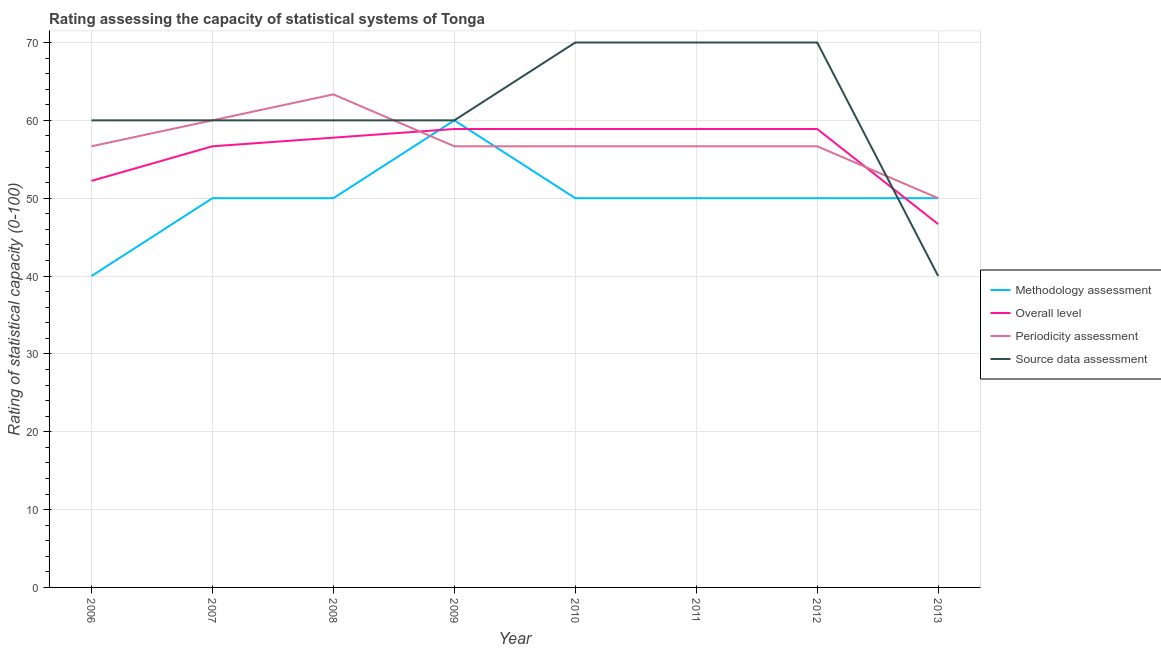How many different coloured lines are there?
Keep it short and to the point. 4. Does the line corresponding to methodology assessment rating intersect with the line corresponding to periodicity assessment rating?
Make the answer very short. Yes. What is the methodology assessment rating in 2009?
Offer a very short reply. 60. Across all years, what is the maximum methodology assessment rating?
Offer a terse response. 60. Across all years, what is the minimum methodology assessment rating?
Keep it short and to the point. 40. In which year was the overall level rating maximum?
Make the answer very short. 2009. In which year was the source data assessment rating minimum?
Make the answer very short. 2013. What is the total methodology assessment rating in the graph?
Make the answer very short. 400. What is the difference between the overall level rating in 2008 and that in 2009?
Make the answer very short. -1.11. What is the difference between the methodology assessment rating in 2007 and the periodicity assessment rating in 2010?
Ensure brevity in your answer.  -6.67. What is the average periodicity assessment rating per year?
Offer a very short reply. 57.08. In the year 2008, what is the difference between the overall level rating and source data assessment rating?
Your answer should be very brief. -2.22. What is the ratio of the source data assessment rating in 2007 to that in 2013?
Your response must be concise. 1.5. Is the source data assessment rating in 2011 less than that in 2012?
Your answer should be compact. No. What is the difference between the highest and the second highest periodicity assessment rating?
Keep it short and to the point. 3.33. What is the difference between the highest and the lowest overall level rating?
Ensure brevity in your answer.  12.22. In how many years, is the overall level rating greater than the average overall level rating taken over all years?
Your answer should be very brief. 6. Is it the case that in every year, the sum of the methodology assessment rating and overall level rating is greater than the periodicity assessment rating?
Offer a very short reply. Yes. Does the overall level rating monotonically increase over the years?
Provide a short and direct response. No. Is the periodicity assessment rating strictly greater than the source data assessment rating over the years?
Your response must be concise. No. How many lines are there?
Offer a very short reply. 4. How many years are there in the graph?
Provide a short and direct response. 8. Are the values on the major ticks of Y-axis written in scientific E-notation?
Your response must be concise. No. Where does the legend appear in the graph?
Provide a succinct answer. Center right. How many legend labels are there?
Ensure brevity in your answer.  4. What is the title of the graph?
Provide a short and direct response. Rating assessing the capacity of statistical systems of Tonga. What is the label or title of the Y-axis?
Make the answer very short. Rating of statistical capacity (0-100). What is the Rating of statistical capacity (0-100) in Overall level in 2006?
Make the answer very short. 52.22. What is the Rating of statistical capacity (0-100) of Periodicity assessment in 2006?
Offer a terse response. 56.67. What is the Rating of statistical capacity (0-100) of Methodology assessment in 2007?
Provide a short and direct response. 50. What is the Rating of statistical capacity (0-100) of Overall level in 2007?
Offer a very short reply. 56.67. What is the Rating of statistical capacity (0-100) of Periodicity assessment in 2007?
Keep it short and to the point. 60. What is the Rating of statistical capacity (0-100) of Source data assessment in 2007?
Provide a short and direct response. 60. What is the Rating of statistical capacity (0-100) of Overall level in 2008?
Offer a terse response. 57.78. What is the Rating of statistical capacity (0-100) in Periodicity assessment in 2008?
Make the answer very short. 63.33. What is the Rating of statistical capacity (0-100) of Overall level in 2009?
Make the answer very short. 58.89. What is the Rating of statistical capacity (0-100) of Periodicity assessment in 2009?
Provide a short and direct response. 56.67. What is the Rating of statistical capacity (0-100) of Methodology assessment in 2010?
Make the answer very short. 50. What is the Rating of statistical capacity (0-100) in Overall level in 2010?
Provide a succinct answer. 58.89. What is the Rating of statistical capacity (0-100) in Periodicity assessment in 2010?
Provide a succinct answer. 56.67. What is the Rating of statistical capacity (0-100) in Methodology assessment in 2011?
Offer a terse response. 50. What is the Rating of statistical capacity (0-100) in Overall level in 2011?
Your response must be concise. 58.89. What is the Rating of statistical capacity (0-100) in Periodicity assessment in 2011?
Your answer should be compact. 56.67. What is the Rating of statistical capacity (0-100) in Source data assessment in 2011?
Ensure brevity in your answer.  70. What is the Rating of statistical capacity (0-100) of Overall level in 2012?
Provide a short and direct response. 58.89. What is the Rating of statistical capacity (0-100) in Periodicity assessment in 2012?
Give a very brief answer. 56.67. What is the Rating of statistical capacity (0-100) in Source data assessment in 2012?
Your answer should be compact. 70. What is the Rating of statistical capacity (0-100) of Overall level in 2013?
Offer a terse response. 46.67. What is the Rating of statistical capacity (0-100) in Source data assessment in 2013?
Offer a terse response. 40. Across all years, what is the maximum Rating of statistical capacity (0-100) of Overall level?
Offer a very short reply. 58.89. Across all years, what is the maximum Rating of statistical capacity (0-100) of Periodicity assessment?
Ensure brevity in your answer.  63.33. Across all years, what is the maximum Rating of statistical capacity (0-100) in Source data assessment?
Your answer should be very brief. 70. Across all years, what is the minimum Rating of statistical capacity (0-100) of Methodology assessment?
Make the answer very short. 40. Across all years, what is the minimum Rating of statistical capacity (0-100) in Overall level?
Your answer should be compact. 46.67. Across all years, what is the minimum Rating of statistical capacity (0-100) of Periodicity assessment?
Your answer should be compact. 50. Across all years, what is the minimum Rating of statistical capacity (0-100) in Source data assessment?
Your response must be concise. 40. What is the total Rating of statistical capacity (0-100) in Overall level in the graph?
Your answer should be very brief. 448.89. What is the total Rating of statistical capacity (0-100) in Periodicity assessment in the graph?
Your answer should be compact. 456.67. What is the total Rating of statistical capacity (0-100) in Source data assessment in the graph?
Your answer should be very brief. 490. What is the difference between the Rating of statistical capacity (0-100) of Methodology assessment in 2006 and that in 2007?
Make the answer very short. -10. What is the difference between the Rating of statistical capacity (0-100) in Overall level in 2006 and that in 2007?
Offer a very short reply. -4.44. What is the difference between the Rating of statistical capacity (0-100) in Periodicity assessment in 2006 and that in 2007?
Provide a succinct answer. -3.33. What is the difference between the Rating of statistical capacity (0-100) of Source data assessment in 2006 and that in 2007?
Provide a short and direct response. 0. What is the difference between the Rating of statistical capacity (0-100) of Methodology assessment in 2006 and that in 2008?
Your response must be concise. -10. What is the difference between the Rating of statistical capacity (0-100) of Overall level in 2006 and that in 2008?
Your response must be concise. -5.56. What is the difference between the Rating of statistical capacity (0-100) of Periodicity assessment in 2006 and that in 2008?
Ensure brevity in your answer.  -6.67. What is the difference between the Rating of statistical capacity (0-100) in Overall level in 2006 and that in 2009?
Your answer should be very brief. -6.67. What is the difference between the Rating of statistical capacity (0-100) in Periodicity assessment in 2006 and that in 2009?
Your response must be concise. 0. What is the difference between the Rating of statistical capacity (0-100) of Overall level in 2006 and that in 2010?
Your answer should be very brief. -6.67. What is the difference between the Rating of statistical capacity (0-100) in Source data assessment in 2006 and that in 2010?
Your answer should be compact. -10. What is the difference between the Rating of statistical capacity (0-100) in Methodology assessment in 2006 and that in 2011?
Offer a terse response. -10. What is the difference between the Rating of statistical capacity (0-100) in Overall level in 2006 and that in 2011?
Provide a succinct answer. -6.67. What is the difference between the Rating of statistical capacity (0-100) in Overall level in 2006 and that in 2012?
Your answer should be very brief. -6.67. What is the difference between the Rating of statistical capacity (0-100) of Methodology assessment in 2006 and that in 2013?
Keep it short and to the point. -10. What is the difference between the Rating of statistical capacity (0-100) in Overall level in 2006 and that in 2013?
Provide a succinct answer. 5.56. What is the difference between the Rating of statistical capacity (0-100) of Overall level in 2007 and that in 2008?
Offer a very short reply. -1.11. What is the difference between the Rating of statistical capacity (0-100) of Periodicity assessment in 2007 and that in 2008?
Provide a succinct answer. -3.33. What is the difference between the Rating of statistical capacity (0-100) of Overall level in 2007 and that in 2009?
Keep it short and to the point. -2.22. What is the difference between the Rating of statistical capacity (0-100) in Source data assessment in 2007 and that in 2009?
Make the answer very short. 0. What is the difference between the Rating of statistical capacity (0-100) in Methodology assessment in 2007 and that in 2010?
Give a very brief answer. 0. What is the difference between the Rating of statistical capacity (0-100) in Overall level in 2007 and that in 2010?
Your answer should be compact. -2.22. What is the difference between the Rating of statistical capacity (0-100) in Periodicity assessment in 2007 and that in 2010?
Provide a succinct answer. 3.33. What is the difference between the Rating of statistical capacity (0-100) in Overall level in 2007 and that in 2011?
Offer a terse response. -2.22. What is the difference between the Rating of statistical capacity (0-100) of Source data assessment in 2007 and that in 2011?
Provide a succinct answer. -10. What is the difference between the Rating of statistical capacity (0-100) of Methodology assessment in 2007 and that in 2012?
Give a very brief answer. 0. What is the difference between the Rating of statistical capacity (0-100) of Overall level in 2007 and that in 2012?
Your response must be concise. -2.22. What is the difference between the Rating of statistical capacity (0-100) in Periodicity assessment in 2007 and that in 2012?
Ensure brevity in your answer.  3.33. What is the difference between the Rating of statistical capacity (0-100) of Periodicity assessment in 2007 and that in 2013?
Give a very brief answer. 10. What is the difference between the Rating of statistical capacity (0-100) of Methodology assessment in 2008 and that in 2009?
Your answer should be compact. -10. What is the difference between the Rating of statistical capacity (0-100) in Overall level in 2008 and that in 2009?
Make the answer very short. -1.11. What is the difference between the Rating of statistical capacity (0-100) of Source data assessment in 2008 and that in 2009?
Keep it short and to the point. 0. What is the difference between the Rating of statistical capacity (0-100) in Overall level in 2008 and that in 2010?
Provide a short and direct response. -1.11. What is the difference between the Rating of statistical capacity (0-100) of Periodicity assessment in 2008 and that in 2010?
Your response must be concise. 6.67. What is the difference between the Rating of statistical capacity (0-100) of Overall level in 2008 and that in 2011?
Make the answer very short. -1.11. What is the difference between the Rating of statistical capacity (0-100) in Source data assessment in 2008 and that in 2011?
Keep it short and to the point. -10. What is the difference between the Rating of statistical capacity (0-100) of Overall level in 2008 and that in 2012?
Give a very brief answer. -1.11. What is the difference between the Rating of statistical capacity (0-100) in Periodicity assessment in 2008 and that in 2012?
Keep it short and to the point. 6.67. What is the difference between the Rating of statistical capacity (0-100) of Source data assessment in 2008 and that in 2012?
Provide a short and direct response. -10. What is the difference between the Rating of statistical capacity (0-100) in Overall level in 2008 and that in 2013?
Keep it short and to the point. 11.11. What is the difference between the Rating of statistical capacity (0-100) in Periodicity assessment in 2008 and that in 2013?
Make the answer very short. 13.33. What is the difference between the Rating of statistical capacity (0-100) in Source data assessment in 2008 and that in 2013?
Your response must be concise. 20. What is the difference between the Rating of statistical capacity (0-100) in Source data assessment in 2009 and that in 2011?
Your response must be concise. -10. What is the difference between the Rating of statistical capacity (0-100) in Overall level in 2009 and that in 2012?
Make the answer very short. 0. What is the difference between the Rating of statistical capacity (0-100) of Periodicity assessment in 2009 and that in 2012?
Give a very brief answer. 0. What is the difference between the Rating of statistical capacity (0-100) of Overall level in 2009 and that in 2013?
Ensure brevity in your answer.  12.22. What is the difference between the Rating of statistical capacity (0-100) in Periodicity assessment in 2009 and that in 2013?
Make the answer very short. 6.67. What is the difference between the Rating of statistical capacity (0-100) of Source data assessment in 2009 and that in 2013?
Keep it short and to the point. 20. What is the difference between the Rating of statistical capacity (0-100) in Overall level in 2010 and that in 2011?
Provide a succinct answer. 0. What is the difference between the Rating of statistical capacity (0-100) in Periodicity assessment in 2010 and that in 2011?
Give a very brief answer. 0. What is the difference between the Rating of statistical capacity (0-100) of Methodology assessment in 2010 and that in 2012?
Offer a very short reply. 0. What is the difference between the Rating of statistical capacity (0-100) of Overall level in 2010 and that in 2012?
Give a very brief answer. 0. What is the difference between the Rating of statistical capacity (0-100) in Periodicity assessment in 2010 and that in 2012?
Keep it short and to the point. 0. What is the difference between the Rating of statistical capacity (0-100) of Source data assessment in 2010 and that in 2012?
Give a very brief answer. 0. What is the difference between the Rating of statistical capacity (0-100) in Methodology assessment in 2010 and that in 2013?
Give a very brief answer. 0. What is the difference between the Rating of statistical capacity (0-100) of Overall level in 2010 and that in 2013?
Your response must be concise. 12.22. What is the difference between the Rating of statistical capacity (0-100) in Overall level in 2011 and that in 2012?
Ensure brevity in your answer.  0. What is the difference between the Rating of statistical capacity (0-100) in Overall level in 2011 and that in 2013?
Your response must be concise. 12.22. What is the difference between the Rating of statistical capacity (0-100) of Methodology assessment in 2012 and that in 2013?
Offer a very short reply. 0. What is the difference between the Rating of statistical capacity (0-100) of Overall level in 2012 and that in 2013?
Provide a short and direct response. 12.22. What is the difference between the Rating of statistical capacity (0-100) of Methodology assessment in 2006 and the Rating of statistical capacity (0-100) of Overall level in 2007?
Provide a succinct answer. -16.67. What is the difference between the Rating of statistical capacity (0-100) in Methodology assessment in 2006 and the Rating of statistical capacity (0-100) in Source data assessment in 2007?
Offer a terse response. -20. What is the difference between the Rating of statistical capacity (0-100) of Overall level in 2006 and the Rating of statistical capacity (0-100) of Periodicity assessment in 2007?
Your answer should be very brief. -7.78. What is the difference between the Rating of statistical capacity (0-100) in Overall level in 2006 and the Rating of statistical capacity (0-100) in Source data assessment in 2007?
Your answer should be very brief. -7.78. What is the difference between the Rating of statistical capacity (0-100) in Periodicity assessment in 2006 and the Rating of statistical capacity (0-100) in Source data assessment in 2007?
Offer a very short reply. -3.33. What is the difference between the Rating of statistical capacity (0-100) of Methodology assessment in 2006 and the Rating of statistical capacity (0-100) of Overall level in 2008?
Give a very brief answer. -17.78. What is the difference between the Rating of statistical capacity (0-100) in Methodology assessment in 2006 and the Rating of statistical capacity (0-100) in Periodicity assessment in 2008?
Give a very brief answer. -23.33. What is the difference between the Rating of statistical capacity (0-100) in Methodology assessment in 2006 and the Rating of statistical capacity (0-100) in Source data assessment in 2008?
Make the answer very short. -20. What is the difference between the Rating of statistical capacity (0-100) of Overall level in 2006 and the Rating of statistical capacity (0-100) of Periodicity assessment in 2008?
Your answer should be compact. -11.11. What is the difference between the Rating of statistical capacity (0-100) of Overall level in 2006 and the Rating of statistical capacity (0-100) of Source data assessment in 2008?
Give a very brief answer. -7.78. What is the difference between the Rating of statistical capacity (0-100) in Methodology assessment in 2006 and the Rating of statistical capacity (0-100) in Overall level in 2009?
Provide a succinct answer. -18.89. What is the difference between the Rating of statistical capacity (0-100) in Methodology assessment in 2006 and the Rating of statistical capacity (0-100) in Periodicity assessment in 2009?
Offer a very short reply. -16.67. What is the difference between the Rating of statistical capacity (0-100) of Overall level in 2006 and the Rating of statistical capacity (0-100) of Periodicity assessment in 2009?
Provide a succinct answer. -4.44. What is the difference between the Rating of statistical capacity (0-100) in Overall level in 2006 and the Rating of statistical capacity (0-100) in Source data assessment in 2009?
Keep it short and to the point. -7.78. What is the difference between the Rating of statistical capacity (0-100) in Periodicity assessment in 2006 and the Rating of statistical capacity (0-100) in Source data assessment in 2009?
Provide a succinct answer. -3.33. What is the difference between the Rating of statistical capacity (0-100) in Methodology assessment in 2006 and the Rating of statistical capacity (0-100) in Overall level in 2010?
Provide a succinct answer. -18.89. What is the difference between the Rating of statistical capacity (0-100) of Methodology assessment in 2006 and the Rating of statistical capacity (0-100) of Periodicity assessment in 2010?
Your answer should be very brief. -16.67. What is the difference between the Rating of statistical capacity (0-100) of Overall level in 2006 and the Rating of statistical capacity (0-100) of Periodicity assessment in 2010?
Make the answer very short. -4.44. What is the difference between the Rating of statistical capacity (0-100) of Overall level in 2006 and the Rating of statistical capacity (0-100) of Source data assessment in 2010?
Ensure brevity in your answer.  -17.78. What is the difference between the Rating of statistical capacity (0-100) in Periodicity assessment in 2006 and the Rating of statistical capacity (0-100) in Source data assessment in 2010?
Your answer should be very brief. -13.33. What is the difference between the Rating of statistical capacity (0-100) in Methodology assessment in 2006 and the Rating of statistical capacity (0-100) in Overall level in 2011?
Offer a very short reply. -18.89. What is the difference between the Rating of statistical capacity (0-100) in Methodology assessment in 2006 and the Rating of statistical capacity (0-100) in Periodicity assessment in 2011?
Your answer should be very brief. -16.67. What is the difference between the Rating of statistical capacity (0-100) of Methodology assessment in 2006 and the Rating of statistical capacity (0-100) of Source data assessment in 2011?
Offer a terse response. -30. What is the difference between the Rating of statistical capacity (0-100) in Overall level in 2006 and the Rating of statistical capacity (0-100) in Periodicity assessment in 2011?
Provide a succinct answer. -4.44. What is the difference between the Rating of statistical capacity (0-100) of Overall level in 2006 and the Rating of statistical capacity (0-100) of Source data assessment in 2011?
Ensure brevity in your answer.  -17.78. What is the difference between the Rating of statistical capacity (0-100) in Periodicity assessment in 2006 and the Rating of statistical capacity (0-100) in Source data assessment in 2011?
Ensure brevity in your answer.  -13.33. What is the difference between the Rating of statistical capacity (0-100) of Methodology assessment in 2006 and the Rating of statistical capacity (0-100) of Overall level in 2012?
Provide a short and direct response. -18.89. What is the difference between the Rating of statistical capacity (0-100) of Methodology assessment in 2006 and the Rating of statistical capacity (0-100) of Periodicity assessment in 2012?
Make the answer very short. -16.67. What is the difference between the Rating of statistical capacity (0-100) in Overall level in 2006 and the Rating of statistical capacity (0-100) in Periodicity assessment in 2012?
Offer a very short reply. -4.44. What is the difference between the Rating of statistical capacity (0-100) in Overall level in 2006 and the Rating of statistical capacity (0-100) in Source data assessment in 2012?
Offer a very short reply. -17.78. What is the difference between the Rating of statistical capacity (0-100) of Periodicity assessment in 2006 and the Rating of statistical capacity (0-100) of Source data assessment in 2012?
Your answer should be compact. -13.33. What is the difference between the Rating of statistical capacity (0-100) of Methodology assessment in 2006 and the Rating of statistical capacity (0-100) of Overall level in 2013?
Offer a terse response. -6.67. What is the difference between the Rating of statistical capacity (0-100) of Methodology assessment in 2006 and the Rating of statistical capacity (0-100) of Source data assessment in 2013?
Your answer should be very brief. 0. What is the difference between the Rating of statistical capacity (0-100) in Overall level in 2006 and the Rating of statistical capacity (0-100) in Periodicity assessment in 2013?
Your answer should be very brief. 2.22. What is the difference between the Rating of statistical capacity (0-100) in Overall level in 2006 and the Rating of statistical capacity (0-100) in Source data assessment in 2013?
Your response must be concise. 12.22. What is the difference between the Rating of statistical capacity (0-100) in Periodicity assessment in 2006 and the Rating of statistical capacity (0-100) in Source data assessment in 2013?
Provide a short and direct response. 16.67. What is the difference between the Rating of statistical capacity (0-100) in Methodology assessment in 2007 and the Rating of statistical capacity (0-100) in Overall level in 2008?
Your answer should be very brief. -7.78. What is the difference between the Rating of statistical capacity (0-100) in Methodology assessment in 2007 and the Rating of statistical capacity (0-100) in Periodicity assessment in 2008?
Your answer should be very brief. -13.33. What is the difference between the Rating of statistical capacity (0-100) in Methodology assessment in 2007 and the Rating of statistical capacity (0-100) in Source data assessment in 2008?
Your answer should be very brief. -10. What is the difference between the Rating of statistical capacity (0-100) of Overall level in 2007 and the Rating of statistical capacity (0-100) of Periodicity assessment in 2008?
Your answer should be very brief. -6.67. What is the difference between the Rating of statistical capacity (0-100) in Overall level in 2007 and the Rating of statistical capacity (0-100) in Source data assessment in 2008?
Keep it short and to the point. -3.33. What is the difference between the Rating of statistical capacity (0-100) of Methodology assessment in 2007 and the Rating of statistical capacity (0-100) of Overall level in 2009?
Offer a terse response. -8.89. What is the difference between the Rating of statistical capacity (0-100) of Methodology assessment in 2007 and the Rating of statistical capacity (0-100) of Periodicity assessment in 2009?
Keep it short and to the point. -6.67. What is the difference between the Rating of statistical capacity (0-100) of Methodology assessment in 2007 and the Rating of statistical capacity (0-100) of Source data assessment in 2009?
Your response must be concise. -10. What is the difference between the Rating of statistical capacity (0-100) in Periodicity assessment in 2007 and the Rating of statistical capacity (0-100) in Source data assessment in 2009?
Keep it short and to the point. 0. What is the difference between the Rating of statistical capacity (0-100) of Methodology assessment in 2007 and the Rating of statistical capacity (0-100) of Overall level in 2010?
Keep it short and to the point. -8.89. What is the difference between the Rating of statistical capacity (0-100) of Methodology assessment in 2007 and the Rating of statistical capacity (0-100) of Periodicity assessment in 2010?
Your answer should be compact. -6.67. What is the difference between the Rating of statistical capacity (0-100) of Overall level in 2007 and the Rating of statistical capacity (0-100) of Source data assessment in 2010?
Ensure brevity in your answer.  -13.33. What is the difference between the Rating of statistical capacity (0-100) of Methodology assessment in 2007 and the Rating of statistical capacity (0-100) of Overall level in 2011?
Your answer should be very brief. -8.89. What is the difference between the Rating of statistical capacity (0-100) of Methodology assessment in 2007 and the Rating of statistical capacity (0-100) of Periodicity assessment in 2011?
Your answer should be compact. -6.67. What is the difference between the Rating of statistical capacity (0-100) in Methodology assessment in 2007 and the Rating of statistical capacity (0-100) in Source data assessment in 2011?
Make the answer very short. -20. What is the difference between the Rating of statistical capacity (0-100) of Overall level in 2007 and the Rating of statistical capacity (0-100) of Source data assessment in 2011?
Keep it short and to the point. -13.33. What is the difference between the Rating of statistical capacity (0-100) of Periodicity assessment in 2007 and the Rating of statistical capacity (0-100) of Source data assessment in 2011?
Provide a short and direct response. -10. What is the difference between the Rating of statistical capacity (0-100) in Methodology assessment in 2007 and the Rating of statistical capacity (0-100) in Overall level in 2012?
Your response must be concise. -8.89. What is the difference between the Rating of statistical capacity (0-100) of Methodology assessment in 2007 and the Rating of statistical capacity (0-100) of Periodicity assessment in 2012?
Provide a succinct answer. -6.67. What is the difference between the Rating of statistical capacity (0-100) in Methodology assessment in 2007 and the Rating of statistical capacity (0-100) in Source data assessment in 2012?
Keep it short and to the point. -20. What is the difference between the Rating of statistical capacity (0-100) of Overall level in 2007 and the Rating of statistical capacity (0-100) of Source data assessment in 2012?
Your answer should be very brief. -13.33. What is the difference between the Rating of statistical capacity (0-100) of Periodicity assessment in 2007 and the Rating of statistical capacity (0-100) of Source data assessment in 2012?
Your answer should be compact. -10. What is the difference between the Rating of statistical capacity (0-100) of Methodology assessment in 2007 and the Rating of statistical capacity (0-100) of Overall level in 2013?
Your answer should be compact. 3.33. What is the difference between the Rating of statistical capacity (0-100) of Methodology assessment in 2007 and the Rating of statistical capacity (0-100) of Periodicity assessment in 2013?
Ensure brevity in your answer.  0. What is the difference between the Rating of statistical capacity (0-100) of Overall level in 2007 and the Rating of statistical capacity (0-100) of Periodicity assessment in 2013?
Your answer should be compact. 6.67. What is the difference between the Rating of statistical capacity (0-100) of Overall level in 2007 and the Rating of statistical capacity (0-100) of Source data assessment in 2013?
Keep it short and to the point. 16.67. What is the difference between the Rating of statistical capacity (0-100) in Methodology assessment in 2008 and the Rating of statistical capacity (0-100) in Overall level in 2009?
Offer a very short reply. -8.89. What is the difference between the Rating of statistical capacity (0-100) in Methodology assessment in 2008 and the Rating of statistical capacity (0-100) in Periodicity assessment in 2009?
Provide a short and direct response. -6.67. What is the difference between the Rating of statistical capacity (0-100) in Methodology assessment in 2008 and the Rating of statistical capacity (0-100) in Source data assessment in 2009?
Your response must be concise. -10. What is the difference between the Rating of statistical capacity (0-100) of Overall level in 2008 and the Rating of statistical capacity (0-100) of Periodicity assessment in 2009?
Your response must be concise. 1.11. What is the difference between the Rating of statistical capacity (0-100) in Overall level in 2008 and the Rating of statistical capacity (0-100) in Source data assessment in 2009?
Your answer should be compact. -2.22. What is the difference between the Rating of statistical capacity (0-100) in Periodicity assessment in 2008 and the Rating of statistical capacity (0-100) in Source data assessment in 2009?
Keep it short and to the point. 3.33. What is the difference between the Rating of statistical capacity (0-100) in Methodology assessment in 2008 and the Rating of statistical capacity (0-100) in Overall level in 2010?
Give a very brief answer. -8.89. What is the difference between the Rating of statistical capacity (0-100) in Methodology assessment in 2008 and the Rating of statistical capacity (0-100) in Periodicity assessment in 2010?
Offer a very short reply. -6.67. What is the difference between the Rating of statistical capacity (0-100) in Overall level in 2008 and the Rating of statistical capacity (0-100) in Source data assessment in 2010?
Your answer should be very brief. -12.22. What is the difference between the Rating of statistical capacity (0-100) in Periodicity assessment in 2008 and the Rating of statistical capacity (0-100) in Source data assessment in 2010?
Provide a short and direct response. -6.67. What is the difference between the Rating of statistical capacity (0-100) of Methodology assessment in 2008 and the Rating of statistical capacity (0-100) of Overall level in 2011?
Provide a short and direct response. -8.89. What is the difference between the Rating of statistical capacity (0-100) of Methodology assessment in 2008 and the Rating of statistical capacity (0-100) of Periodicity assessment in 2011?
Your response must be concise. -6.67. What is the difference between the Rating of statistical capacity (0-100) in Methodology assessment in 2008 and the Rating of statistical capacity (0-100) in Source data assessment in 2011?
Provide a short and direct response. -20. What is the difference between the Rating of statistical capacity (0-100) of Overall level in 2008 and the Rating of statistical capacity (0-100) of Periodicity assessment in 2011?
Your answer should be very brief. 1.11. What is the difference between the Rating of statistical capacity (0-100) in Overall level in 2008 and the Rating of statistical capacity (0-100) in Source data assessment in 2011?
Provide a short and direct response. -12.22. What is the difference between the Rating of statistical capacity (0-100) in Periodicity assessment in 2008 and the Rating of statistical capacity (0-100) in Source data assessment in 2011?
Keep it short and to the point. -6.67. What is the difference between the Rating of statistical capacity (0-100) of Methodology assessment in 2008 and the Rating of statistical capacity (0-100) of Overall level in 2012?
Make the answer very short. -8.89. What is the difference between the Rating of statistical capacity (0-100) in Methodology assessment in 2008 and the Rating of statistical capacity (0-100) in Periodicity assessment in 2012?
Provide a short and direct response. -6.67. What is the difference between the Rating of statistical capacity (0-100) in Methodology assessment in 2008 and the Rating of statistical capacity (0-100) in Source data assessment in 2012?
Your response must be concise. -20. What is the difference between the Rating of statistical capacity (0-100) of Overall level in 2008 and the Rating of statistical capacity (0-100) of Periodicity assessment in 2012?
Provide a short and direct response. 1.11. What is the difference between the Rating of statistical capacity (0-100) in Overall level in 2008 and the Rating of statistical capacity (0-100) in Source data assessment in 2012?
Offer a very short reply. -12.22. What is the difference between the Rating of statistical capacity (0-100) of Periodicity assessment in 2008 and the Rating of statistical capacity (0-100) of Source data assessment in 2012?
Provide a short and direct response. -6.67. What is the difference between the Rating of statistical capacity (0-100) of Methodology assessment in 2008 and the Rating of statistical capacity (0-100) of Overall level in 2013?
Your answer should be very brief. 3.33. What is the difference between the Rating of statistical capacity (0-100) of Overall level in 2008 and the Rating of statistical capacity (0-100) of Periodicity assessment in 2013?
Ensure brevity in your answer.  7.78. What is the difference between the Rating of statistical capacity (0-100) in Overall level in 2008 and the Rating of statistical capacity (0-100) in Source data assessment in 2013?
Keep it short and to the point. 17.78. What is the difference between the Rating of statistical capacity (0-100) in Periodicity assessment in 2008 and the Rating of statistical capacity (0-100) in Source data assessment in 2013?
Ensure brevity in your answer.  23.33. What is the difference between the Rating of statistical capacity (0-100) in Methodology assessment in 2009 and the Rating of statistical capacity (0-100) in Overall level in 2010?
Provide a short and direct response. 1.11. What is the difference between the Rating of statistical capacity (0-100) in Methodology assessment in 2009 and the Rating of statistical capacity (0-100) in Source data assessment in 2010?
Your response must be concise. -10. What is the difference between the Rating of statistical capacity (0-100) of Overall level in 2009 and the Rating of statistical capacity (0-100) of Periodicity assessment in 2010?
Make the answer very short. 2.22. What is the difference between the Rating of statistical capacity (0-100) in Overall level in 2009 and the Rating of statistical capacity (0-100) in Source data assessment in 2010?
Offer a very short reply. -11.11. What is the difference between the Rating of statistical capacity (0-100) in Periodicity assessment in 2009 and the Rating of statistical capacity (0-100) in Source data assessment in 2010?
Offer a very short reply. -13.33. What is the difference between the Rating of statistical capacity (0-100) of Methodology assessment in 2009 and the Rating of statistical capacity (0-100) of Periodicity assessment in 2011?
Keep it short and to the point. 3.33. What is the difference between the Rating of statistical capacity (0-100) of Methodology assessment in 2009 and the Rating of statistical capacity (0-100) of Source data assessment in 2011?
Provide a short and direct response. -10. What is the difference between the Rating of statistical capacity (0-100) of Overall level in 2009 and the Rating of statistical capacity (0-100) of Periodicity assessment in 2011?
Your answer should be compact. 2.22. What is the difference between the Rating of statistical capacity (0-100) in Overall level in 2009 and the Rating of statistical capacity (0-100) in Source data assessment in 2011?
Offer a very short reply. -11.11. What is the difference between the Rating of statistical capacity (0-100) of Periodicity assessment in 2009 and the Rating of statistical capacity (0-100) of Source data assessment in 2011?
Make the answer very short. -13.33. What is the difference between the Rating of statistical capacity (0-100) in Methodology assessment in 2009 and the Rating of statistical capacity (0-100) in Overall level in 2012?
Provide a succinct answer. 1.11. What is the difference between the Rating of statistical capacity (0-100) in Methodology assessment in 2009 and the Rating of statistical capacity (0-100) in Periodicity assessment in 2012?
Your answer should be compact. 3.33. What is the difference between the Rating of statistical capacity (0-100) in Overall level in 2009 and the Rating of statistical capacity (0-100) in Periodicity assessment in 2012?
Ensure brevity in your answer.  2.22. What is the difference between the Rating of statistical capacity (0-100) of Overall level in 2009 and the Rating of statistical capacity (0-100) of Source data assessment in 2012?
Keep it short and to the point. -11.11. What is the difference between the Rating of statistical capacity (0-100) of Periodicity assessment in 2009 and the Rating of statistical capacity (0-100) of Source data assessment in 2012?
Offer a terse response. -13.33. What is the difference between the Rating of statistical capacity (0-100) in Methodology assessment in 2009 and the Rating of statistical capacity (0-100) in Overall level in 2013?
Make the answer very short. 13.33. What is the difference between the Rating of statistical capacity (0-100) of Methodology assessment in 2009 and the Rating of statistical capacity (0-100) of Periodicity assessment in 2013?
Offer a very short reply. 10. What is the difference between the Rating of statistical capacity (0-100) of Overall level in 2009 and the Rating of statistical capacity (0-100) of Periodicity assessment in 2013?
Your answer should be compact. 8.89. What is the difference between the Rating of statistical capacity (0-100) in Overall level in 2009 and the Rating of statistical capacity (0-100) in Source data assessment in 2013?
Your response must be concise. 18.89. What is the difference between the Rating of statistical capacity (0-100) of Periodicity assessment in 2009 and the Rating of statistical capacity (0-100) of Source data assessment in 2013?
Offer a very short reply. 16.67. What is the difference between the Rating of statistical capacity (0-100) of Methodology assessment in 2010 and the Rating of statistical capacity (0-100) of Overall level in 2011?
Offer a very short reply. -8.89. What is the difference between the Rating of statistical capacity (0-100) in Methodology assessment in 2010 and the Rating of statistical capacity (0-100) in Periodicity assessment in 2011?
Provide a short and direct response. -6.67. What is the difference between the Rating of statistical capacity (0-100) of Overall level in 2010 and the Rating of statistical capacity (0-100) of Periodicity assessment in 2011?
Your response must be concise. 2.22. What is the difference between the Rating of statistical capacity (0-100) of Overall level in 2010 and the Rating of statistical capacity (0-100) of Source data assessment in 2011?
Ensure brevity in your answer.  -11.11. What is the difference between the Rating of statistical capacity (0-100) in Periodicity assessment in 2010 and the Rating of statistical capacity (0-100) in Source data assessment in 2011?
Provide a succinct answer. -13.33. What is the difference between the Rating of statistical capacity (0-100) of Methodology assessment in 2010 and the Rating of statistical capacity (0-100) of Overall level in 2012?
Your answer should be compact. -8.89. What is the difference between the Rating of statistical capacity (0-100) in Methodology assessment in 2010 and the Rating of statistical capacity (0-100) in Periodicity assessment in 2012?
Provide a succinct answer. -6.67. What is the difference between the Rating of statistical capacity (0-100) in Methodology assessment in 2010 and the Rating of statistical capacity (0-100) in Source data assessment in 2012?
Your answer should be compact. -20. What is the difference between the Rating of statistical capacity (0-100) in Overall level in 2010 and the Rating of statistical capacity (0-100) in Periodicity assessment in 2012?
Offer a very short reply. 2.22. What is the difference between the Rating of statistical capacity (0-100) of Overall level in 2010 and the Rating of statistical capacity (0-100) of Source data assessment in 2012?
Provide a short and direct response. -11.11. What is the difference between the Rating of statistical capacity (0-100) in Periodicity assessment in 2010 and the Rating of statistical capacity (0-100) in Source data assessment in 2012?
Offer a terse response. -13.33. What is the difference between the Rating of statistical capacity (0-100) of Methodology assessment in 2010 and the Rating of statistical capacity (0-100) of Periodicity assessment in 2013?
Your answer should be compact. 0. What is the difference between the Rating of statistical capacity (0-100) of Overall level in 2010 and the Rating of statistical capacity (0-100) of Periodicity assessment in 2013?
Provide a short and direct response. 8.89. What is the difference between the Rating of statistical capacity (0-100) of Overall level in 2010 and the Rating of statistical capacity (0-100) of Source data assessment in 2013?
Your response must be concise. 18.89. What is the difference between the Rating of statistical capacity (0-100) in Periodicity assessment in 2010 and the Rating of statistical capacity (0-100) in Source data assessment in 2013?
Keep it short and to the point. 16.67. What is the difference between the Rating of statistical capacity (0-100) of Methodology assessment in 2011 and the Rating of statistical capacity (0-100) of Overall level in 2012?
Offer a very short reply. -8.89. What is the difference between the Rating of statistical capacity (0-100) in Methodology assessment in 2011 and the Rating of statistical capacity (0-100) in Periodicity assessment in 2012?
Your answer should be compact. -6.67. What is the difference between the Rating of statistical capacity (0-100) of Overall level in 2011 and the Rating of statistical capacity (0-100) of Periodicity assessment in 2012?
Ensure brevity in your answer.  2.22. What is the difference between the Rating of statistical capacity (0-100) in Overall level in 2011 and the Rating of statistical capacity (0-100) in Source data assessment in 2012?
Keep it short and to the point. -11.11. What is the difference between the Rating of statistical capacity (0-100) of Periodicity assessment in 2011 and the Rating of statistical capacity (0-100) of Source data assessment in 2012?
Your answer should be very brief. -13.33. What is the difference between the Rating of statistical capacity (0-100) of Methodology assessment in 2011 and the Rating of statistical capacity (0-100) of Overall level in 2013?
Provide a succinct answer. 3.33. What is the difference between the Rating of statistical capacity (0-100) in Methodology assessment in 2011 and the Rating of statistical capacity (0-100) in Periodicity assessment in 2013?
Keep it short and to the point. 0. What is the difference between the Rating of statistical capacity (0-100) in Methodology assessment in 2011 and the Rating of statistical capacity (0-100) in Source data assessment in 2013?
Your answer should be compact. 10. What is the difference between the Rating of statistical capacity (0-100) of Overall level in 2011 and the Rating of statistical capacity (0-100) of Periodicity assessment in 2013?
Your response must be concise. 8.89. What is the difference between the Rating of statistical capacity (0-100) of Overall level in 2011 and the Rating of statistical capacity (0-100) of Source data assessment in 2013?
Your answer should be compact. 18.89. What is the difference between the Rating of statistical capacity (0-100) of Periodicity assessment in 2011 and the Rating of statistical capacity (0-100) of Source data assessment in 2013?
Your answer should be very brief. 16.67. What is the difference between the Rating of statistical capacity (0-100) in Methodology assessment in 2012 and the Rating of statistical capacity (0-100) in Overall level in 2013?
Provide a succinct answer. 3.33. What is the difference between the Rating of statistical capacity (0-100) of Methodology assessment in 2012 and the Rating of statistical capacity (0-100) of Source data assessment in 2013?
Offer a very short reply. 10. What is the difference between the Rating of statistical capacity (0-100) in Overall level in 2012 and the Rating of statistical capacity (0-100) in Periodicity assessment in 2013?
Give a very brief answer. 8.89. What is the difference between the Rating of statistical capacity (0-100) in Overall level in 2012 and the Rating of statistical capacity (0-100) in Source data assessment in 2013?
Your response must be concise. 18.89. What is the difference between the Rating of statistical capacity (0-100) of Periodicity assessment in 2012 and the Rating of statistical capacity (0-100) of Source data assessment in 2013?
Keep it short and to the point. 16.67. What is the average Rating of statistical capacity (0-100) in Methodology assessment per year?
Provide a succinct answer. 50. What is the average Rating of statistical capacity (0-100) of Overall level per year?
Keep it short and to the point. 56.11. What is the average Rating of statistical capacity (0-100) in Periodicity assessment per year?
Offer a terse response. 57.08. What is the average Rating of statistical capacity (0-100) of Source data assessment per year?
Keep it short and to the point. 61.25. In the year 2006, what is the difference between the Rating of statistical capacity (0-100) of Methodology assessment and Rating of statistical capacity (0-100) of Overall level?
Give a very brief answer. -12.22. In the year 2006, what is the difference between the Rating of statistical capacity (0-100) in Methodology assessment and Rating of statistical capacity (0-100) in Periodicity assessment?
Keep it short and to the point. -16.67. In the year 2006, what is the difference between the Rating of statistical capacity (0-100) of Overall level and Rating of statistical capacity (0-100) of Periodicity assessment?
Keep it short and to the point. -4.44. In the year 2006, what is the difference between the Rating of statistical capacity (0-100) in Overall level and Rating of statistical capacity (0-100) in Source data assessment?
Provide a short and direct response. -7.78. In the year 2007, what is the difference between the Rating of statistical capacity (0-100) in Methodology assessment and Rating of statistical capacity (0-100) in Overall level?
Your answer should be compact. -6.67. In the year 2007, what is the difference between the Rating of statistical capacity (0-100) in Overall level and Rating of statistical capacity (0-100) in Periodicity assessment?
Provide a short and direct response. -3.33. In the year 2008, what is the difference between the Rating of statistical capacity (0-100) of Methodology assessment and Rating of statistical capacity (0-100) of Overall level?
Your answer should be very brief. -7.78. In the year 2008, what is the difference between the Rating of statistical capacity (0-100) in Methodology assessment and Rating of statistical capacity (0-100) in Periodicity assessment?
Give a very brief answer. -13.33. In the year 2008, what is the difference between the Rating of statistical capacity (0-100) of Overall level and Rating of statistical capacity (0-100) of Periodicity assessment?
Provide a short and direct response. -5.56. In the year 2008, what is the difference between the Rating of statistical capacity (0-100) of Overall level and Rating of statistical capacity (0-100) of Source data assessment?
Your answer should be very brief. -2.22. In the year 2008, what is the difference between the Rating of statistical capacity (0-100) of Periodicity assessment and Rating of statistical capacity (0-100) of Source data assessment?
Keep it short and to the point. 3.33. In the year 2009, what is the difference between the Rating of statistical capacity (0-100) in Methodology assessment and Rating of statistical capacity (0-100) in Overall level?
Offer a very short reply. 1.11. In the year 2009, what is the difference between the Rating of statistical capacity (0-100) in Overall level and Rating of statistical capacity (0-100) in Periodicity assessment?
Offer a very short reply. 2.22. In the year 2009, what is the difference between the Rating of statistical capacity (0-100) in Overall level and Rating of statistical capacity (0-100) in Source data assessment?
Your response must be concise. -1.11. In the year 2009, what is the difference between the Rating of statistical capacity (0-100) in Periodicity assessment and Rating of statistical capacity (0-100) in Source data assessment?
Give a very brief answer. -3.33. In the year 2010, what is the difference between the Rating of statistical capacity (0-100) of Methodology assessment and Rating of statistical capacity (0-100) of Overall level?
Make the answer very short. -8.89. In the year 2010, what is the difference between the Rating of statistical capacity (0-100) in Methodology assessment and Rating of statistical capacity (0-100) in Periodicity assessment?
Offer a terse response. -6.67. In the year 2010, what is the difference between the Rating of statistical capacity (0-100) in Methodology assessment and Rating of statistical capacity (0-100) in Source data assessment?
Provide a short and direct response. -20. In the year 2010, what is the difference between the Rating of statistical capacity (0-100) of Overall level and Rating of statistical capacity (0-100) of Periodicity assessment?
Provide a succinct answer. 2.22. In the year 2010, what is the difference between the Rating of statistical capacity (0-100) of Overall level and Rating of statistical capacity (0-100) of Source data assessment?
Make the answer very short. -11.11. In the year 2010, what is the difference between the Rating of statistical capacity (0-100) in Periodicity assessment and Rating of statistical capacity (0-100) in Source data assessment?
Keep it short and to the point. -13.33. In the year 2011, what is the difference between the Rating of statistical capacity (0-100) of Methodology assessment and Rating of statistical capacity (0-100) of Overall level?
Ensure brevity in your answer.  -8.89. In the year 2011, what is the difference between the Rating of statistical capacity (0-100) in Methodology assessment and Rating of statistical capacity (0-100) in Periodicity assessment?
Your answer should be very brief. -6.67. In the year 2011, what is the difference between the Rating of statistical capacity (0-100) in Overall level and Rating of statistical capacity (0-100) in Periodicity assessment?
Provide a succinct answer. 2.22. In the year 2011, what is the difference between the Rating of statistical capacity (0-100) of Overall level and Rating of statistical capacity (0-100) of Source data assessment?
Offer a very short reply. -11.11. In the year 2011, what is the difference between the Rating of statistical capacity (0-100) of Periodicity assessment and Rating of statistical capacity (0-100) of Source data assessment?
Offer a very short reply. -13.33. In the year 2012, what is the difference between the Rating of statistical capacity (0-100) of Methodology assessment and Rating of statistical capacity (0-100) of Overall level?
Give a very brief answer. -8.89. In the year 2012, what is the difference between the Rating of statistical capacity (0-100) in Methodology assessment and Rating of statistical capacity (0-100) in Periodicity assessment?
Your answer should be very brief. -6.67. In the year 2012, what is the difference between the Rating of statistical capacity (0-100) in Methodology assessment and Rating of statistical capacity (0-100) in Source data assessment?
Provide a succinct answer. -20. In the year 2012, what is the difference between the Rating of statistical capacity (0-100) in Overall level and Rating of statistical capacity (0-100) in Periodicity assessment?
Your response must be concise. 2.22. In the year 2012, what is the difference between the Rating of statistical capacity (0-100) in Overall level and Rating of statistical capacity (0-100) in Source data assessment?
Make the answer very short. -11.11. In the year 2012, what is the difference between the Rating of statistical capacity (0-100) of Periodicity assessment and Rating of statistical capacity (0-100) of Source data assessment?
Your answer should be very brief. -13.33. In the year 2013, what is the difference between the Rating of statistical capacity (0-100) in Methodology assessment and Rating of statistical capacity (0-100) in Overall level?
Offer a very short reply. 3.33. In the year 2013, what is the difference between the Rating of statistical capacity (0-100) of Methodology assessment and Rating of statistical capacity (0-100) of Periodicity assessment?
Your response must be concise. 0. In the year 2013, what is the difference between the Rating of statistical capacity (0-100) in Overall level and Rating of statistical capacity (0-100) in Source data assessment?
Keep it short and to the point. 6.67. What is the ratio of the Rating of statistical capacity (0-100) in Methodology assessment in 2006 to that in 2007?
Provide a succinct answer. 0.8. What is the ratio of the Rating of statistical capacity (0-100) of Overall level in 2006 to that in 2007?
Offer a very short reply. 0.92. What is the ratio of the Rating of statistical capacity (0-100) in Periodicity assessment in 2006 to that in 2007?
Ensure brevity in your answer.  0.94. What is the ratio of the Rating of statistical capacity (0-100) of Source data assessment in 2006 to that in 2007?
Make the answer very short. 1. What is the ratio of the Rating of statistical capacity (0-100) of Overall level in 2006 to that in 2008?
Offer a very short reply. 0.9. What is the ratio of the Rating of statistical capacity (0-100) of Periodicity assessment in 2006 to that in 2008?
Make the answer very short. 0.89. What is the ratio of the Rating of statistical capacity (0-100) of Source data assessment in 2006 to that in 2008?
Make the answer very short. 1. What is the ratio of the Rating of statistical capacity (0-100) in Overall level in 2006 to that in 2009?
Offer a very short reply. 0.89. What is the ratio of the Rating of statistical capacity (0-100) of Periodicity assessment in 2006 to that in 2009?
Keep it short and to the point. 1. What is the ratio of the Rating of statistical capacity (0-100) in Overall level in 2006 to that in 2010?
Make the answer very short. 0.89. What is the ratio of the Rating of statistical capacity (0-100) of Source data assessment in 2006 to that in 2010?
Offer a very short reply. 0.86. What is the ratio of the Rating of statistical capacity (0-100) of Methodology assessment in 2006 to that in 2011?
Your response must be concise. 0.8. What is the ratio of the Rating of statistical capacity (0-100) of Overall level in 2006 to that in 2011?
Ensure brevity in your answer.  0.89. What is the ratio of the Rating of statistical capacity (0-100) in Source data assessment in 2006 to that in 2011?
Give a very brief answer. 0.86. What is the ratio of the Rating of statistical capacity (0-100) of Methodology assessment in 2006 to that in 2012?
Provide a short and direct response. 0.8. What is the ratio of the Rating of statistical capacity (0-100) in Overall level in 2006 to that in 2012?
Make the answer very short. 0.89. What is the ratio of the Rating of statistical capacity (0-100) in Periodicity assessment in 2006 to that in 2012?
Provide a short and direct response. 1. What is the ratio of the Rating of statistical capacity (0-100) of Methodology assessment in 2006 to that in 2013?
Make the answer very short. 0.8. What is the ratio of the Rating of statistical capacity (0-100) of Overall level in 2006 to that in 2013?
Provide a succinct answer. 1.12. What is the ratio of the Rating of statistical capacity (0-100) in Periodicity assessment in 2006 to that in 2013?
Keep it short and to the point. 1.13. What is the ratio of the Rating of statistical capacity (0-100) of Overall level in 2007 to that in 2008?
Ensure brevity in your answer.  0.98. What is the ratio of the Rating of statistical capacity (0-100) of Methodology assessment in 2007 to that in 2009?
Your answer should be very brief. 0.83. What is the ratio of the Rating of statistical capacity (0-100) of Overall level in 2007 to that in 2009?
Your answer should be compact. 0.96. What is the ratio of the Rating of statistical capacity (0-100) of Periodicity assessment in 2007 to that in 2009?
Offer a terse response. 1.06. What is the ratio of the Rating of statistical capacity (0-100) in Source data assessment in 2007 to that in 2009?
Provide a short and direct response. 1. What is the ratio of the Rating of statistical capacity (0-100) in Overall level in 2007 to that in 2010?
Keep it short and to the point. 0.96. What is the ratio of the Rating of statistical capacity (0-100) of Periodicity assessment in 2007 to that in 2010?
Ensure brevity in your answer.  1.06. What is the ratio of the Rating of statistical capacity (0-100) of Source data assessment in 2007 to that in 2010?
Give a very brief answer. 0.86. What is the ratio of the Rating of statistical capacity (0-100) of Methodology assessment in 2007 to that in 2011?
Your answer should be compact. 1. What is the ratio of the Rating of statistical capacity (0-100) of Overall level in 2007 to that in 2011?
Ensure brevity in your answer.  0.96. What is the ratio of the Rating of statistical capacity (0-100) in Periodicity assessment in 2007 to that in 2011?
Ensure brevity in your answer.  1.06. What is the ratio of the Rating of statistical capacity (0-100) in Source data assessment in 2007 to that in 2011?
Give a very brief answer. 0.86. What is the ratio of the Rating of statistical capacity (0-100) in Methodology assessment in 2007 to that in 2012?
Make the answer very short. 1. What is the ratio of the Rating of statistical capacity (0-100) of Overall level in 2007 to that in 2012?
Your response must be concise. 0.96. What is the ratio of the Rating of statistical capacity (0-100) in Periodicity assessment in 2007 to that in 2012?
Provide a short and direct response. 1.06. What is the ratio of the Rating of statistical capacity (0-100) in Overall level in 2007 to that in 2013?
Your answer should be very brief. 1.21. What is the ratio of the Rating of statistical capacity (0-100) of Periodicity assessment in 2007 to that in 2013?
Your answer should be very brief. 1.2. What is the ratio of the Rating of statistical capacity (0-100) of Methodology assessment in 2008 to that in 2009?
Make the answer very short. 0.83. What is the ratio of the Rating of statistical capacity (0-100) of Overall level in 2008 to that in 2009?
Your answer should be compact. 0.98. What is the ratio of the Rating of statistical capacity (0-100) in Periodicity assessment in 2008 to that in 2009?
Provide a short and direct response. 1.12. What is the ratio of the Rating of statistical capacity (0-100) of Source data assessment in 2008 to that in 2009?
Provide a succinct answer. 1. What is the ratio of the Rating of statistical capacity (0-100) in Overall level in 2008 to that in 2010?
Your answer should be compact. 0.98. What is the ratio of the Rating of statistical capacity (0-100) in Periodicity assessment in 2008 to that in 2010?
Provide a succinct answer. 1.12. What is the ratio of the Rating of statistical capacity (0-100) in Source data assessment in 2008 to that in 2010?
Ensure brevity in your answer.  0.86. What is the ratio of the Rating of statistical capacity (0-100) of Methodology assessment in 2008 to that in 2011?
Ensure brevity in your answer.  1. What is the ratio of the Rating of statistical capacity (0-100) of Overall level in 2008 to that in 2011?
Your response must be concise. 0.98. What is the ratio of the Rating of statistical capacity (0-100) in Periodicity assessment in 2008 to that in 2011?
Make the answer very short. 1.12. What is the ratio of the Rating of statistical capacity (0-100) of Source data assessment in 2008 to that in 2011?
Offer a terse response. 0.86. What is the ratio of the Rating of statistical capacity (0-100) of Methodology assessment in 2008 to that in 2012?
Ensure brevity in your answer.  1. What is the ratio of the Rating of statistical capacity (0-100) of Overall level in 2008 to that in 2012?
Ensure brevity in your answer.  0.98. What is the ratio of the Rating of statistical capacity (0-100) in Periodicity assessment in 2008 to that in 2012?
Provide a succinct answer. 1.12. What is the ratio of the Rating of statistical capacity (0-100) of Overall level in 2008 to that in 2013?
Make the answer very short. 1.24. What is the ratio of the Rating of statistical capacity (0-100) of Periodicity assessment in 2008 to that in 2013?
Your answer should be compact. 1.27. What is the ratio of the Rating of statistical capacity (0-100) in Methodology assessment in 2009 to that in 2010?
Keep it short and to the point. 1.2. What is the ratio of the Rating of statistical capacity (0-100) of Source data assessment in 2009 to that in 2010?
Provide a succinct answer. 0.86. What is the ratio of the Rating of statistical capacity (0-100) in Methodology assessment in 2009 to that in 2011?
Provide a short and direct response. 1.2. What is the ratio of the Rating of statistical capacity (0-100) in Overall level in 2009 to that in 2011?
Your answer should be very brief. 1. What is the ratio of the Rating of statistical capacity (0-100) of Periodicity assessment in 2009 to that in 2011?
Provide a short and direct response. 1. What is the ratio of the Rating of statistical capacity (0-100) of Source data assessment in 2009 to that in 2011?
Your response must be concise. 0.86. What is the ratio of the Rating of statistical capacity (0-100) of Overall level in 2009 to that in 2013?
Keep it short and to the point. 1.26. What is the ratio of the Rating of statistical capacity (0-100) of Periodicity assessment in 2009 to that in 2013?
Give a very brief answer. 1.13. What is the ratio of the Rating of statistical capacity (0-100) of Periodicity assessment in 2010 to that in 2011?
Your response must be concise. 1. What is the ratio of the Rating of statistical capacity (0-100) in Source data assessment in 2010 to that in 2011?
Offer a terse response. 1. What is the ratio of the Rating of statistical capacity (0-100) of Methodology assessment in 2010 to that in 2012?
Offer a terse response. 1. What is the ratio of the Rating of statistical capacity (0-100) of Source data assessment in 2010 to that in 2012?
Give a very brief answer. 1. What is the ratio of the Rating of statistical capacity (0-100) in Overall level in 2010 to that in 2013?
Make the answer very short. 1.26. What is the ratio of the Rating of statistical capacity (0-100) in Periodicity assessment in 2010 to that in 2013?
Provide a succinct answer. 1.13. What is the ratio of the Rating of statistical capacity (0-100) of Source data assessment in 2010 to that in 2013?
Provide a short and direct response. 1.75. What is the ratio of the Rating of statistical capacity (0-100) of Methodology assessment in 2011 to that in 2012?
Your answer should be compact. 1. What is the ratio of the Rating of statistical capacity (0-100) of Overall level in 2011 to that in 2013?
Provide a succinct answer. 1.26. What is the ratio of the Rating of statistical capacity (0-100) in Periodicity assessment in 2011 to that in 2013?
Keep it short and to the point. 1.13. What is the ratio of the Rating of statistical capacity (0-100) of Source data assessment in 2011 to that in 2013?
Your response must be concise. 1.75. What is the ratio of the Rating of statistical capacity (0-100) in Methodology assessment in 2012 to that in 2013?
Give a very brief answer. 1. What is the ratio of the Rating of statistical capacity (0-100) of Overall level in 2012 to that in 2013?
Give a very brief answer. 1.26. What is the ratio of the Rating of statistical capacity (0-100) in Periodicity assessment in 2012 to that in 2013?
Give a very brief answer. 1.13. What is the difference between the highest and the second highest Rating of statistical capacity (0-100) of Methodology assessment?
Ensure brevity in your answer.  10. What is the difference between the highest and the second highest Rating of statistical capacity (0-100) in Periodicity assessment?
Give a very brief answer. 3.33. What is the difference between the highest and the lowest Rating of statistical capacity (0-100) of Overall level?
Ensure brevity in your answer.  12.22. What is the difference between the highest and the lowest Rating of statistical capacity (0-100) in Periodicity assessment?
Your response must be concise. 13.33. What is the difference between the highest and the lowest Rating of statistical capacity (0-100) of Source data assessment?
Make the answer very short. 30. 